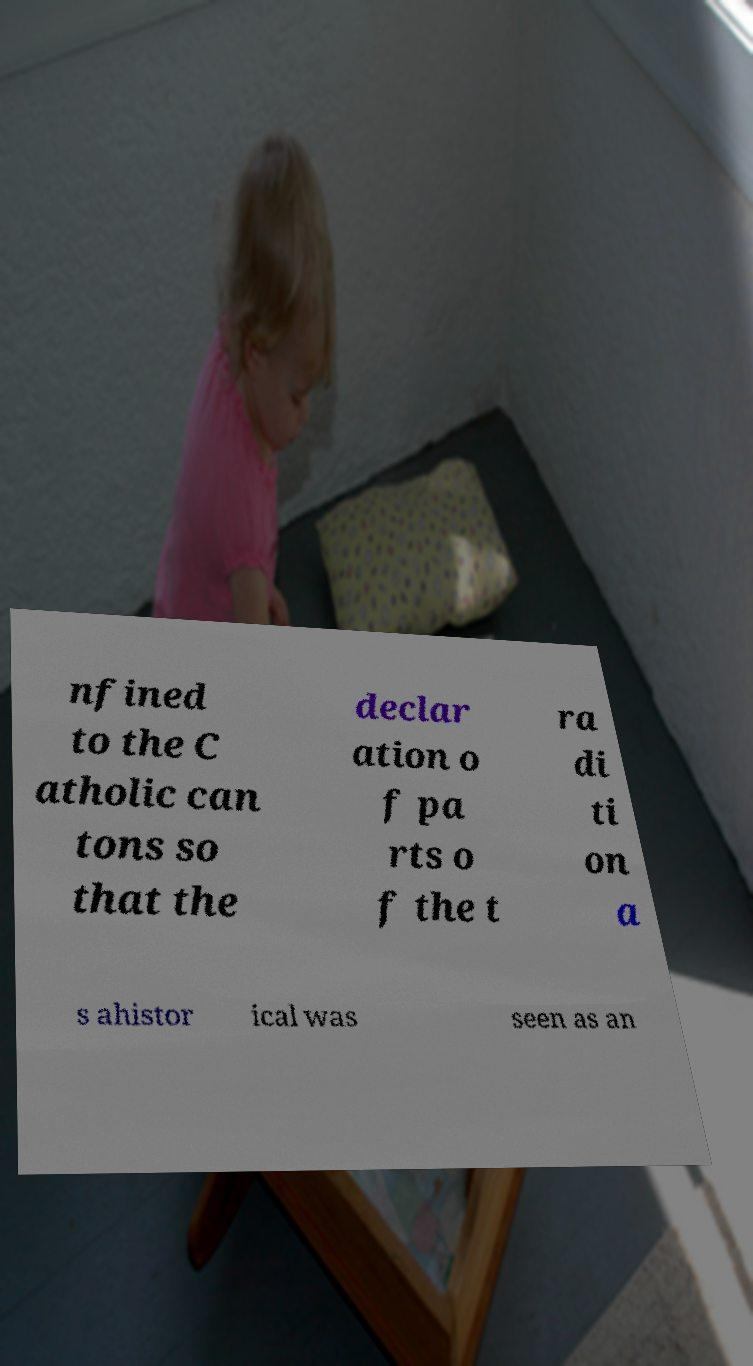I need the written content from this picture converted into text. Can you do that? nfined to the C atholic can tons so that the declar ation o f pa rts o f the t ra di ti on a s ahistor ical was seen as an 